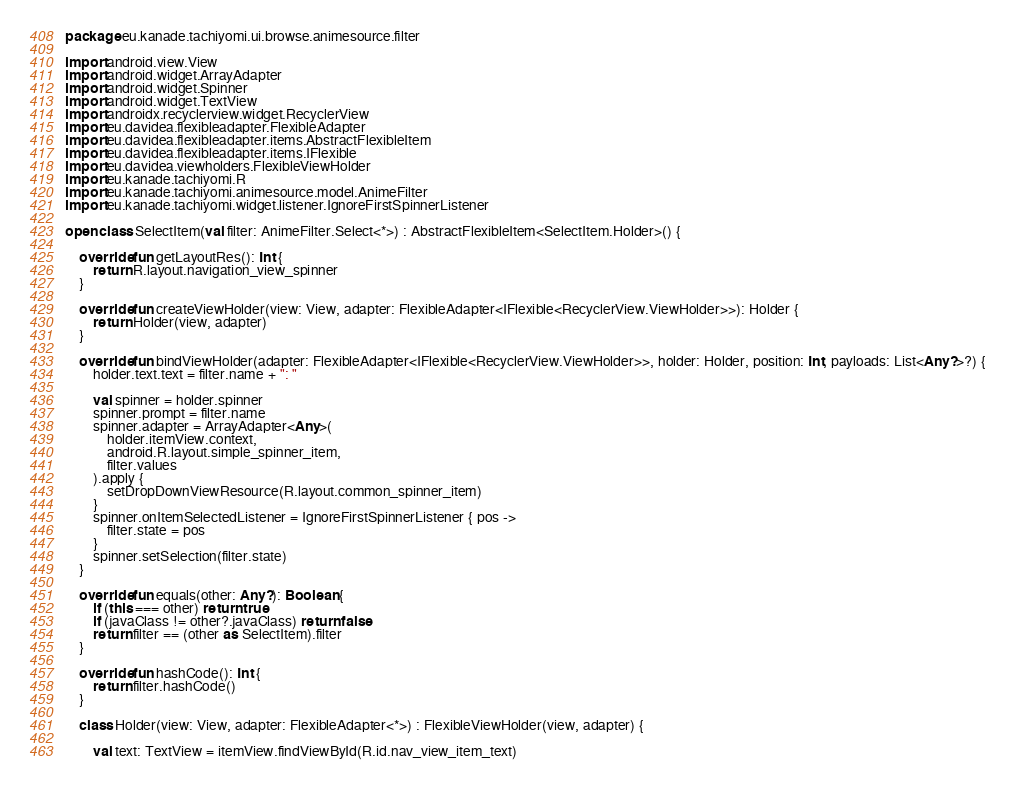<code> <loc_0><loc_0><loc_500><loc_500><_Kotlin_>package eu.kanade.tachiyomi.ui.browse.animesource.filter

import android.view.View
import android.widget.ArrayAdapter
import android.widget.Spinner
import android.widget.TextView
import androidx.recyclerview.widget.RecyclerView
import eu.davidea.flexibleadapter.FlexibleAdapter
import eu.davidea.flexibleadapter.items.AbstractFlexibleItem
import eu.davidea.flexibleadapter.items.IFlexible
import eu.davidea.viewholders.FlexibleViewHolder
import eu.kanade.tachiyomi.R
import eu.kanade.tachiyomi.animesource.model.AnimeFilter
import eu.kanade.tachiyomi.widget.listener.IgnoreFirstSpinnerListener

open class SelectItem(val filter: AnimeFilter.Select<*>) : AbstractFlexibleItem<SelectItem.Holder>() {

    override fun getLayoutRes(): Int {
        return R.layout.navigation_view_spinner
    }

    override fun createViewHolder(view: View, adapter: FlexibleAdapter<IFlexible<RecyclerView.ViewHolder>>): Holder {
        return Holder(view, adapter)
    }

    override fun bindViewHolder(adapter: FlexibleAdapter<IFlexible<RecyclerView.ViewHolder>>, holder: Holder, position: Int, payloads: List<Any?>?) {
        holder.text.text = filter.name + ": "

        val spinner = holder.spinner
        spinner.prompt = filter.name
        spinner.adapter = ArrayAdapter<Any>(
            holder.itemView.context,
            android.R.layout.simple_spinner_item,
            filter.values
        ).apply {
            setDropDownViewResource(R.layout.common_spinner_item)
        }
        spinner.onItemSelectedListener = IgnoreFirstSpinnerListener { pos ->
            filter.state = pos
        }
        spinner.setSelection(filter.state)
    }

    override fun equals(other: Any?): Boolean {
        if (this === other) return true
        if (javaClass != other?.javaClass) return false
        return filter == (other as SelectItem).filter
    }

    override fun hashCode(): Int {
        return filter.hashCode()
    }

    class Holder(view: View, adapter: FlexibleAdapter<*>) : FlexibleViewHolder(view, adapter) {

        val text: TextView = itemView.findViewById(R.id.nav_view_item_text)</code> 